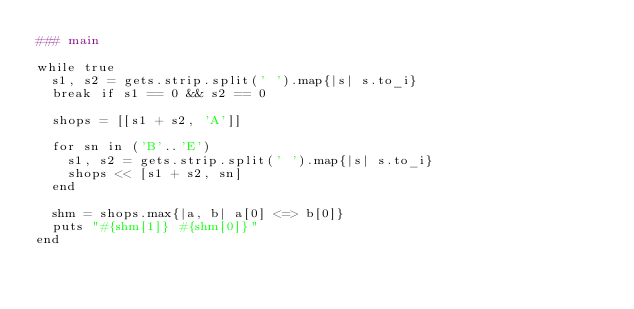<code> <loc_0><loc_0><loc_500><loc_500><_Ruby_>### main

while true
  s1, s2 = gets.strip.split(' ').map{|s| s.to_i}
  break if s1 == 0 && s2 == 0

  shops = [[s1 + s2, 'A']]

  for sn in ('B'..'E')
    s1, s2 = gets.strip.split(' ').map{|s| s.to_i}
    shops << [s1 + s2, sn]
  end

  shm = shops.max{|a, b| a[0] <=> b[0]}
  puts "#{shm[1]} #{shm[0]}"
end</code> 